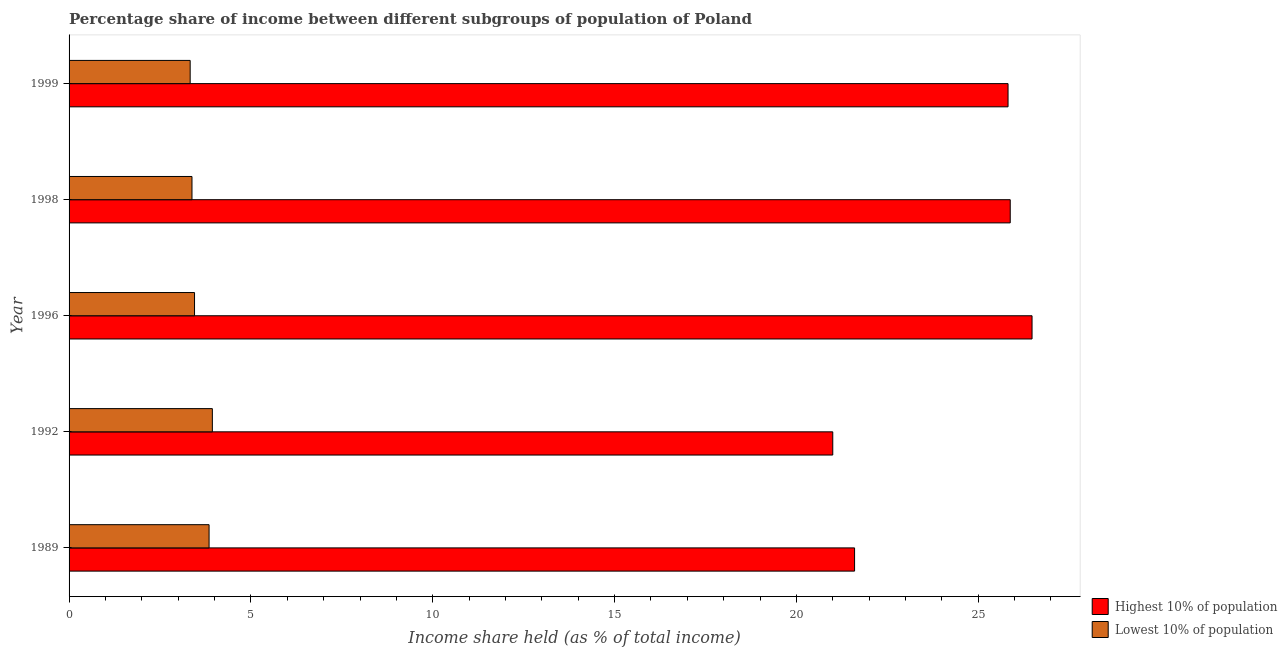How many different coloured bars are there?
Your response must be concise. 2. How many groups of bars are there?
Provide a short and direct response. 5. Are the number of bars per tick equal to the number of legend labels?
Your answer should be compact. Yes. Are the number of bars on each tick of the Y-axis equal?
Offer a terse response. Yes. How many bars are there on the 2nd tick from the bottom?
Your answer should be very brief. 2. What is the income share held by highest 10% of the population in 1989?
Offer a terse response. 21.6. Across all years, what is the maximum income share held by lowest 10% of the population?
Keep it short and to the point. 3.94. Across all years, what is the minimum income share held by lowest 10% of the population?
Give a very brief answer. 3.33. In which year was the income share held by highest 10% of the population minimum?
Your answer should be compact. 1992. What is the total income share held by lowest 10% of the population in the graph?
Offer a very short reply. 17.95. What is the difference between the income share held by lowest 10% of the population in 1996 and that in 1999?
Offer a terse response. 0.12. What is the difference between the income share held by highest 10% of the population in 1989 and the income share held by lowest 10% of the population in 1996?
Offer a very short reply. 18.15. What is the average income share held by highest 10% of the population per year?
Your answer should be compact. 24.16. In the year 1989, what is the difference between the income share held by highest 10% of the population and income share held by lowest 10% of the population?
Offer a terse response. 17.75. What is the ratio of the income share held by lowest 10% of the population in 1989 to that in 1998?
Make the answer very short. 1.14. Is the difference between the income share held by highest 10% of the population in 1989 and 1999 greater than the difference between the income share held by lowest 10% of the population in 1989 and 1999?
Your answer should be compact. No. What is the difference between the highest and the second highest income share held by lowest 10% of the population?
Give a very brief answer. 0.09. What is the difference between the highest and the lowest income share held by lowest 10% of the population?
Give a very brief answer. 0.61. Is the sum of the income share held by lowest 10% of the population in 1992 and 1999 greater than the maximum income share held by highest 10% of the population across all years?
Make the answer very short. No. What does the 1st bar from the top in 1992 represents?
Give a very brief answer. Lowest 10% of population. What does the 2nd bar from the bottom in 1989 represents?
Offer a terse response. Lowest 10% of population. How many bars are there?
Ensure brevity in your answer.  10. Does the graph contain any zero values?
Offer a terse response. No. Does the graph contain grids?
Ensure brevity in your answer.  No. Where does the legend appear in the graph?
Ensure brevity in your answer.  Bottom right. How many legend labels are there?
Make the answer very short. 2. What is the title of the graph?
Offer a very short reply. Percentage share of income between different subgroups of population of Poland. What is the label or title of the X-axis?
Offer a very short reply. Income share held (as % of total income). What is the Income share held (as % of total income) in Highest 10% of population in 1989?
Give a very brief answer. 21.6. What is the Income share held (as % of total income) of Lowest 10% of population in 1989?
Your answer should be very brief. 3.85. What is the Income share held (as % of total income) in Highest 10% of population in 1992?
Give a very brief answer. 21. What is the Income share held (as % of total income) of Lowest 10% of population in 1992?
Your answer should be very brief. 3.94. What is the Income share held (as % of total income) of Highest 10% of population in 1996?
Keep it short and to the point. 26.48. What is the Income share held (as % of total income) in Lowest 10% of population in 1996?
Your answer should be very brief. 3.45. What is the Income share held (as % of total income) in Highest 10% of population in 1998?
Provide a short and direct response. 25.88. What is the Income share held (as % of total income) in Lowest 10% of population in 1998?
Your answer should be very brief. 3.38. What is the Income share held (as % of total income) in Highest 10% of population in 1999?
Offer a terse response. 25.82. What is the Income share held (as % of total income) in Lowest 10% of population in 1999?
Give a very brief answer. 3.33. Across all years, what is the maximum Income share held (as % of total income) of Highest 10% of population?
Offer a very short reply. 26.48. Across all years, what is the maximum Income share held (as % of total income) in Lowest 10% of population?
Keep it short and to the point. 3.94. Across all years, what is the minimum Income share held (as % of total income) in Highest 10% of population?
Offer a very short reply. 21. Across all years, what is the minimum Income share held (as % of total income) of Lowest 10% of population?
Your response must be concise. 3.33. What is the total Income share held (as % of total income) in Highest 10% of population in the graph?
Your response must be concise. 120.78. What is the total Income share held (as % of total income) in Lowest 10% of population in the graph?
Make the answer very short. 17.95. What is the difference between the Income share held (as % of total income) of Lowest 10% of population in 1989 and that in 1992?
Your answer should be very brief. -0.09. What is the difference between the Income share held (as % of total income) in Highest 10% of population in 1989 and that in 1996?
Your response must be concise. -4.88. What is the difference between the Income share held (as % of total income) in Highest 10% of population in 1989 and that in 1998?
Provide a succinct answer. -4.28. What is the difference between the Income share held (as % of total income) in Lowest 10% of population in 1989 and that in 1998?
Keep it short and to the point. 0.47. What is the difference between the Income share held (as % of total income) of Highest 10% of population in 1989 and that in 1999?
Provide a succinct answer. -4.22. What is the difference between the Income share held (as % of total income) of Lowest 10% of population in 1989 and that in 1999?
Offer a very short reply. 0.52. What is the difference between the Income share held (as % of total income) in Highest 10% of population in 1992 and that in 1996?
Ensure brevity in your answer.  -5.48. What is the difference between the Income share held (as % of total income) in Lowest 10% of population in 1992 and that in 1996?
Make the answer very short. 0.49. What is the difference between the Income share held (as % of total income) of Highest 10% of population in 1992 and that in 1998?
Offer a terse response. -4.88. What is the difference between the Income share held (as % of total income) in Lowest 10% of population in 1992 and that in 1998?
Your response must be concise. 0.56. What is the difference between the Income share held (as % of total income) in Highest 10% of population in 1992 and that in 1999?
Your response must be concise. -4.82. What is the difference between the Income share held (as % of total income) in Lowest 10% of population in 1992 and that in 1999?
Offer a very short reply. 0.61. What is the difference between the Income share held (as % of total income) in Lowest 10% of population in 1996 and that in 1998?
Give a very brief answer. 0.07. What is the difference between the Income share held (as % of total income) of Highest 10% of population in 1996 and that in 1999?
Offer a very short reply. 0.66. What is the difference between the Income share held (as % of total income) of Lowest 10% of population in 1996 and that in 1999?
Offer a terse response. 0.12. What is the difference between the Income share held (as % of total income) of Highest 10% of population in 1989 and the Income share held (as % of total income) of Lowest 10% of population in 1992?
Keep it short and to the point. 17.66. What is the difference between the Income share held (as % of total income) of Highest 10% of population in 1989 and the Income share held (as % of total income) of Lowest 10% of population in 1996?
Give a very brief answer. 18.15. What is the difference between the Income share held (as % of total income) of Highest 10% of population in 1989 and the Income share held (as % of total income) of Lowest 10% of population in 1998?
Your answer should be very brief. 18.22. What is the difference between the Income share held (as % of total income) of Highest 10% of population in 1989 and the Income share held (as % of total income) of Lowest 10% of population in 1999?
Your answer should be very brief. 18.27. What is the difference between the Income share held (as % of total income) in Highest 10% of population in 1992 and the Income share held (as % of total income) in Lowest 10% of population in 1996?
Provide a succinct answer. 17.55. What is the difference between the Income share held (as % of total income) in Highest 10% of population in 1992 and the Income share held (as % of total income) in Lowest 10% of population in 1998?
Provide a succinct answer. 17.62. What is the difference between the Income share held (as % of total income) of Highest 10% of population in 1992 and the Income share held (as % of total income) of Lowest 10% of population in 1999?
Give a very brief answer. 17.67. What is the difference between the Income share held (as % of total income) of Highest 10% of population in 1996 and the Income share held (as % of total income) of Lowest 10% of population in 1998?
Offer a very short reply. 23.1. What is the difference between the Income share held (as % of total income) of Highest 10% of population in 1996 and the Income share held (as % of total income) of Lowest 10% of population in 1999?
Provide a short and direct response. 23.15. What is the difference between the Income share held (as % of total income) of Highest 10% of population in 1998 and the Income share held (as % of total income) of Lowest 10% of population in 1999?
Make the answer very short. 22.55. What is the average Income share held (as % of total income) in Highest 10% of population per year?
Give a very brief answer. 24.16. What is the average Income share held (as % of total income) of Lowest 10% of population per year?
Ensure brevity in your answer.  3.59. In the year 1989, what is the difference between the Income share held (as % of total income) of Highest 10% of population and Income share held (as % of total income) of Lowest 10% of population?
Your answer should be compact. 17.75. In the year 1992, what is the difference between the Income share held (as % of total income) of Highest 10% of population and Income share held (as % of total income) of Lowest 10% of population?
Ensure brevity in your answer.  17.06. In the year 1996, what is the difference between the Income share held (as % of total income) in Highest 10% of population and Income share held (as % of total income) in Lowest 10% of population?
Make the answer very short. 23.03. In the year 1998, what is the difference between the Income share held (as % of total income) of Highest 10% of population and Income share held (as % of total income) of Lowest 10% of population?
Provide a succinct answer. 22.5. In the year 1999, what is the difference between the Income share held (as % of total income) in Highest 10% of population and Income share held (as % of total income) in Lowest 10% of population?
Make the answer very short. 22.49. What is the ratio of the Income share held (as % of total income) in Highest 10% of population in 1989 to that in 1992?
Your answer should be compact. 1.03. What is the ratio of the Income share held (as % of total income) of Lowest 10% of population in 1989 to that in 1992?
Make the answer very short. 0.98. What is the ratio of the Income share held (as % of total income) of Highest 10% of population in 1989 to that in 1996?
Keep it short and to the point. 0.82. What is the ratio of the Income share held (as % of total income) of Lowest 10% of population in 1989 to that in 1996?
Your response must be concise. 1.12. What is the ratio of the Income share held (as % of total income) in Highest 10% of population in 1989 to that in 1998?
Your answer should be very brief. 0.83. What is the ratio of the Income share held (as % of total income) of Lowest 10% of population in 1989 to that in 1998?
Ensure brevity in your answer.  1.14. What is the ratio of the Income share held (as % of total income) of Highest 10% of population in 1989 to that in 1999?
Offer a very short reply. 0.84. What is the ratio of the Income share held (as % of total income) of Lowest 10% of population in 1989 to that in 1999?
Keep it short and to the point. 1.16. What is the ratio of the Income share held (as % of total income) of Highest 10% of population in 1992 to that in 1996?
Offer a terse response. 0.79. What is the ratio of the Income share held (as % of total income) of Lowest 10% of population in 1992 to that in 1996?
Make the answer very short. 1.14. What is the ratio of the Income share held (as % of total income) of Highest 10% of population in 1992 to that in 1998?
Offer a very short reply. 0.81. What is the ratio of the Income share held (as % of total income) of Lowest 10% of population in 1992 to that in 1998?
Your answer should be compact. 1.17. What is the ratio of the Income share held (as % of total income) of Highest 10% of population in 1992 to that in 1999?
Your response must be concise. 0.81. What is the ratio of the Income share held (as % of total income) of Lowest 10% of population in 1992 to that in 1999?
Provide a short and direct response. 1.18. What is the ratio of the Income share held (as % of total income) of Highest 10% of population in 1996 to that in 1998?
Your answer should be very brief. 1.02. What is the ratio of the Income share held (as % of total income) of Lowest 10% of population in 1996 to that in 1998?
Your answer should be compact. 1.02. What is the ratio of the Income share held (as % of total income) of Highest 10% of population in 1996 to that in 1999?
Your answer should be very brief. 1.03. What is the ratio of the Income share held (as % of total income) in Lowest 10% of population in 1996 to that in 1999?
Offer a terse response. 1.04. What is the difference between the highest and the second highest Income share held (as % of total income) of Lowest 10% of population?
Your response must be concise. 0.09. What is the difference between the highest and the lowest Income share held (as % of total income) of Highest 10% of population?
Provide a short and direct response. 5.48. What is the difference between the highest and the lowest Income share held (as % of total income) in Lowest 10% of population?
Give a very brief answer. 0.61. 